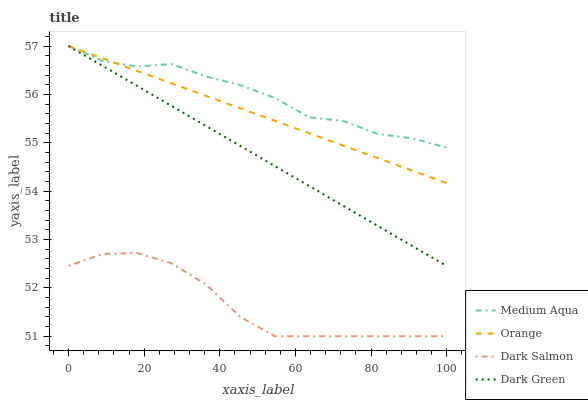Does Medium Aqua have the minimum area under the curve?
Answer yes or no. No. Does Dark Salmon have the maximum area under the curve?
Answer yes or no. No. Is Dark Salmon the smoothest?
Answer yes or no. No. Is Dark Salmon the roughest?
Answer yes or no. No. Does Medium Aqua have the lowest value?
Answer yes or no. No. Does Dark Salmon have the highest value?
Answer yes or no. No. Is Dark Salmon less than Medium Aqua?
Answer yes or no. Yes. Is Orange greater than Dark Salmon?
Answer yes or no. Yes. Does Dark Salmon intersect Medium Aqua?
Answer yes or no. No. 